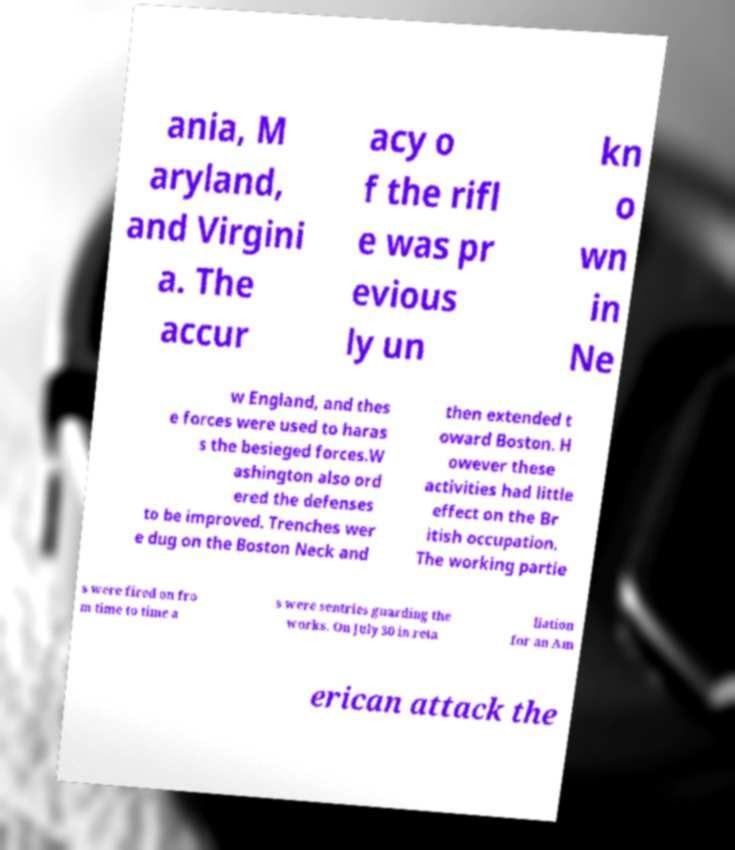Please read and relay the text visible in this image. What does it say? ania, M aryland, and Virgini a. The accur acy o f the rifl e was pr evious ly un kn o wn in Ne w England, and thes e forces were used to haras s the besieged forces.W ashington also ord ered the defenses to be improved. Trenches wer e dug on the Boston Neck and then extended t oward Boston. H owever these activities had little effect on the Br itish occupation. The working partie s were fired on fro m time to time a s were sentries guarding the works. On July 30 in reta liation for an Am erican attack the 